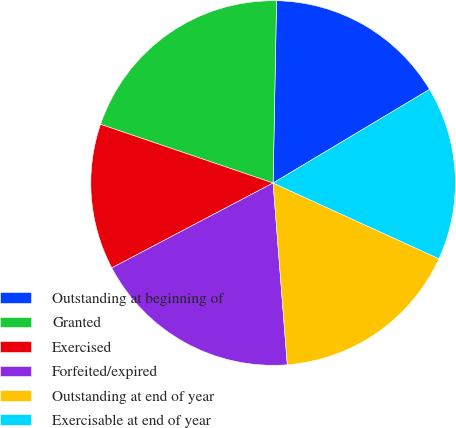Convert chart to OTSL. <chart><loc_0><loc_0><loc_500><loc_500><pie_chart><fcel>Outstanding at beginning of<fcel>Granted<fcel>Exercised<fcel>Forfeited/expired<fcel>Outstanding at end of year<fcel>Exercisable at end of year<nl><fcel>16.12%<fcel>20.08%<fcel>12.93%<fcel>18.53%<fcel>16.94%<fcel>15.4%<nl></chart> 